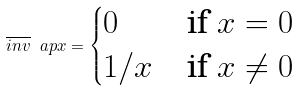Convert formula to latex. <formula><loc_0><loc_0><loc_500><loc_500>\overline { i n v } \ a p x = \begin{cases} 0 & \text {if} \ x = 0 \\ 1 / x & \text {if} \ x \neq 0 \end{cases}</formula> 